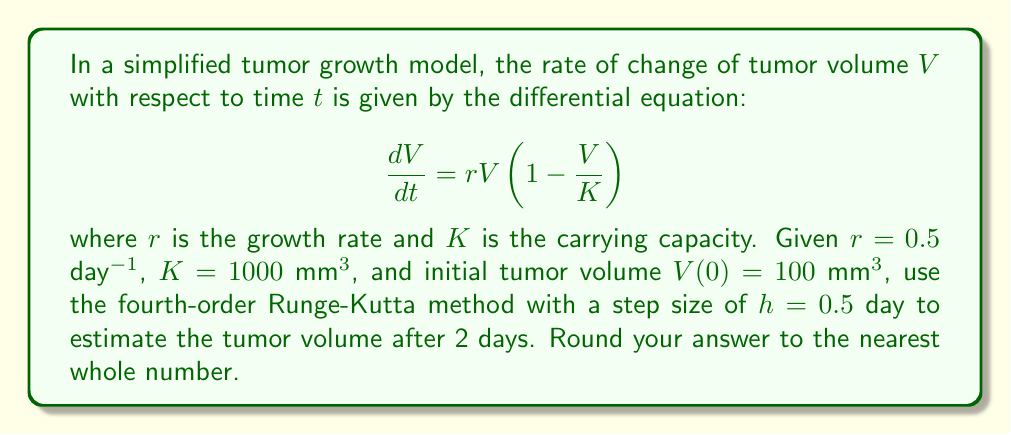Could you help me with this problem? To solve this problem, we'll use the fourth-order Runge-Kutta (RK4) method. The general form of the RK4 method for a differential equation $\frac{dy}{dt} = f(t,y)$ is:

$$y_{n+1} = y_n + \frac{1}{6}(k_1 + 2k_2 + 2k_3 + k_4)$$

where:
$$\begin{align*}
k_1 &= hf(t_n, y_n) \\
k_2 &= hf(t_n + \frac{h}{2}, y_n + \frac{k_1}{2}) \\
k_3 &= hf(t_n + \frac{h}{2}, y_n + \frac{k_2}{2}) \\
k_4 &= hf(t_n + h, y_n + k_3)
\end{align*}$$

In our case, $f(t,V) = rV(1 - \frac{V}{K})$.

Given:
- $r = 0.5$ day$^{-1}$
- $K = 1000$ mm$^3$
- $V(0) = 100$ mm$^3$
- $h = 0.5$ day
- We need to estimate $V(2)$, so we'll need 4 iterations $(2/0.5 = 4)$

Let's calculate step by step:

Iteration 1 ($t_0 = 0$, $V_0 = 100$):
$$\begin{align*}
k_1 &= 0.5 \cdot 0.5 \cdot 100(1 - \frac{100}{1000}) = 22.5 \\
k_2 &= 0.5 \cdot 0.5 \cdot (100 + \frac{22.5}{2})(1 - \frac{100 + \frac{22.5}{2}}{1000}) = 23.9859 \\
k_3 &= 0.5 \cdot 0.5 \cdot (100 + \frac{23.9859}{2})(1 - \frac{100 + \frac{23.9859}{2}}{1000}) = 24.1277 \\
k_4 &= 0.5 \cdot 0.5 \cdot (100 + 24.1277)(1 - \frac{100 + 24.1277}{1000}) = 25.4686
\end{align*}$$

$V_1 = 100 + \frac{1}{6}(22.5 + 2(23.9859) + 2(24.1277) + 25.4686) = 124.0493$

Iteration 2 ($t_1 = 0.5$, $V_1 = 124.0493$):
$$\begin{align*}
k_1 &= 26.4605 \\
k_2 &= 28.2841 \\
k_3 &= 28.4674 \\
k_4 &= 30.2270
\end{align*}$$

$V_2 = 152.6151$

Iteration 3 ($t_2 = 1$, $V_2 = 152.6151$):
$$\begin{align*}
k_1 &= 30.5230 \\
k_2 &= 32.8041 \\
k_3 &= 33.0403 \\
k_4 &= 35.2836
\end{align*}$$

$V_3 = 186.1382$

Iteration 4 ($t_3 = 1.5$, $V_3 = 186.1382$):
$$\begin{align*}
k_1 &= 34.4256 \\
k_2 &= 37.1841 \\
k_3 &= 37.4845 \\
k_4 &= 40.2327
\end{align*}$$

$V_4 = 224.8998$

Therefore, the estimated tumor volume after 2 days is approximately 224.8998 mm$^3$.
Answer: 225 mm$^3$ 